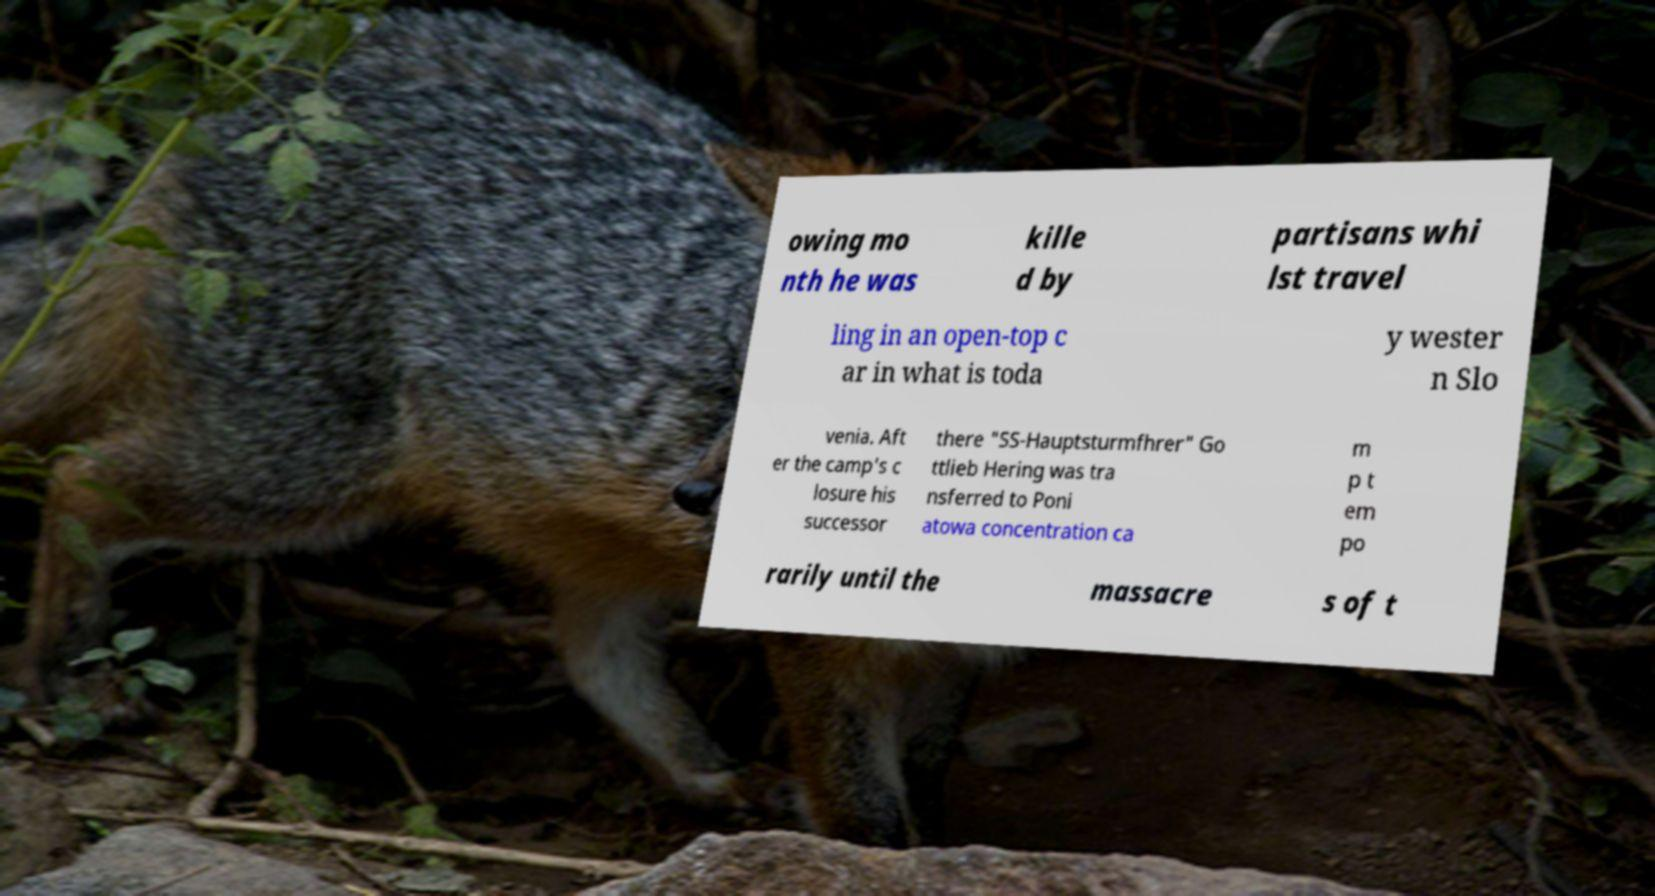Please identify and transcribe the text found in this image. owing mo nth he was kille d by partisans whi lst travel ling in an open-top c ar in what is toda y wester n Slo venia. Aft er the camp's c losure his successor there "SS-Hauptsturmfhrer" Go ttlieb Hering was tra nsferred to Poni atowa concentration ca m p t em po rarily until the massacre s of t 